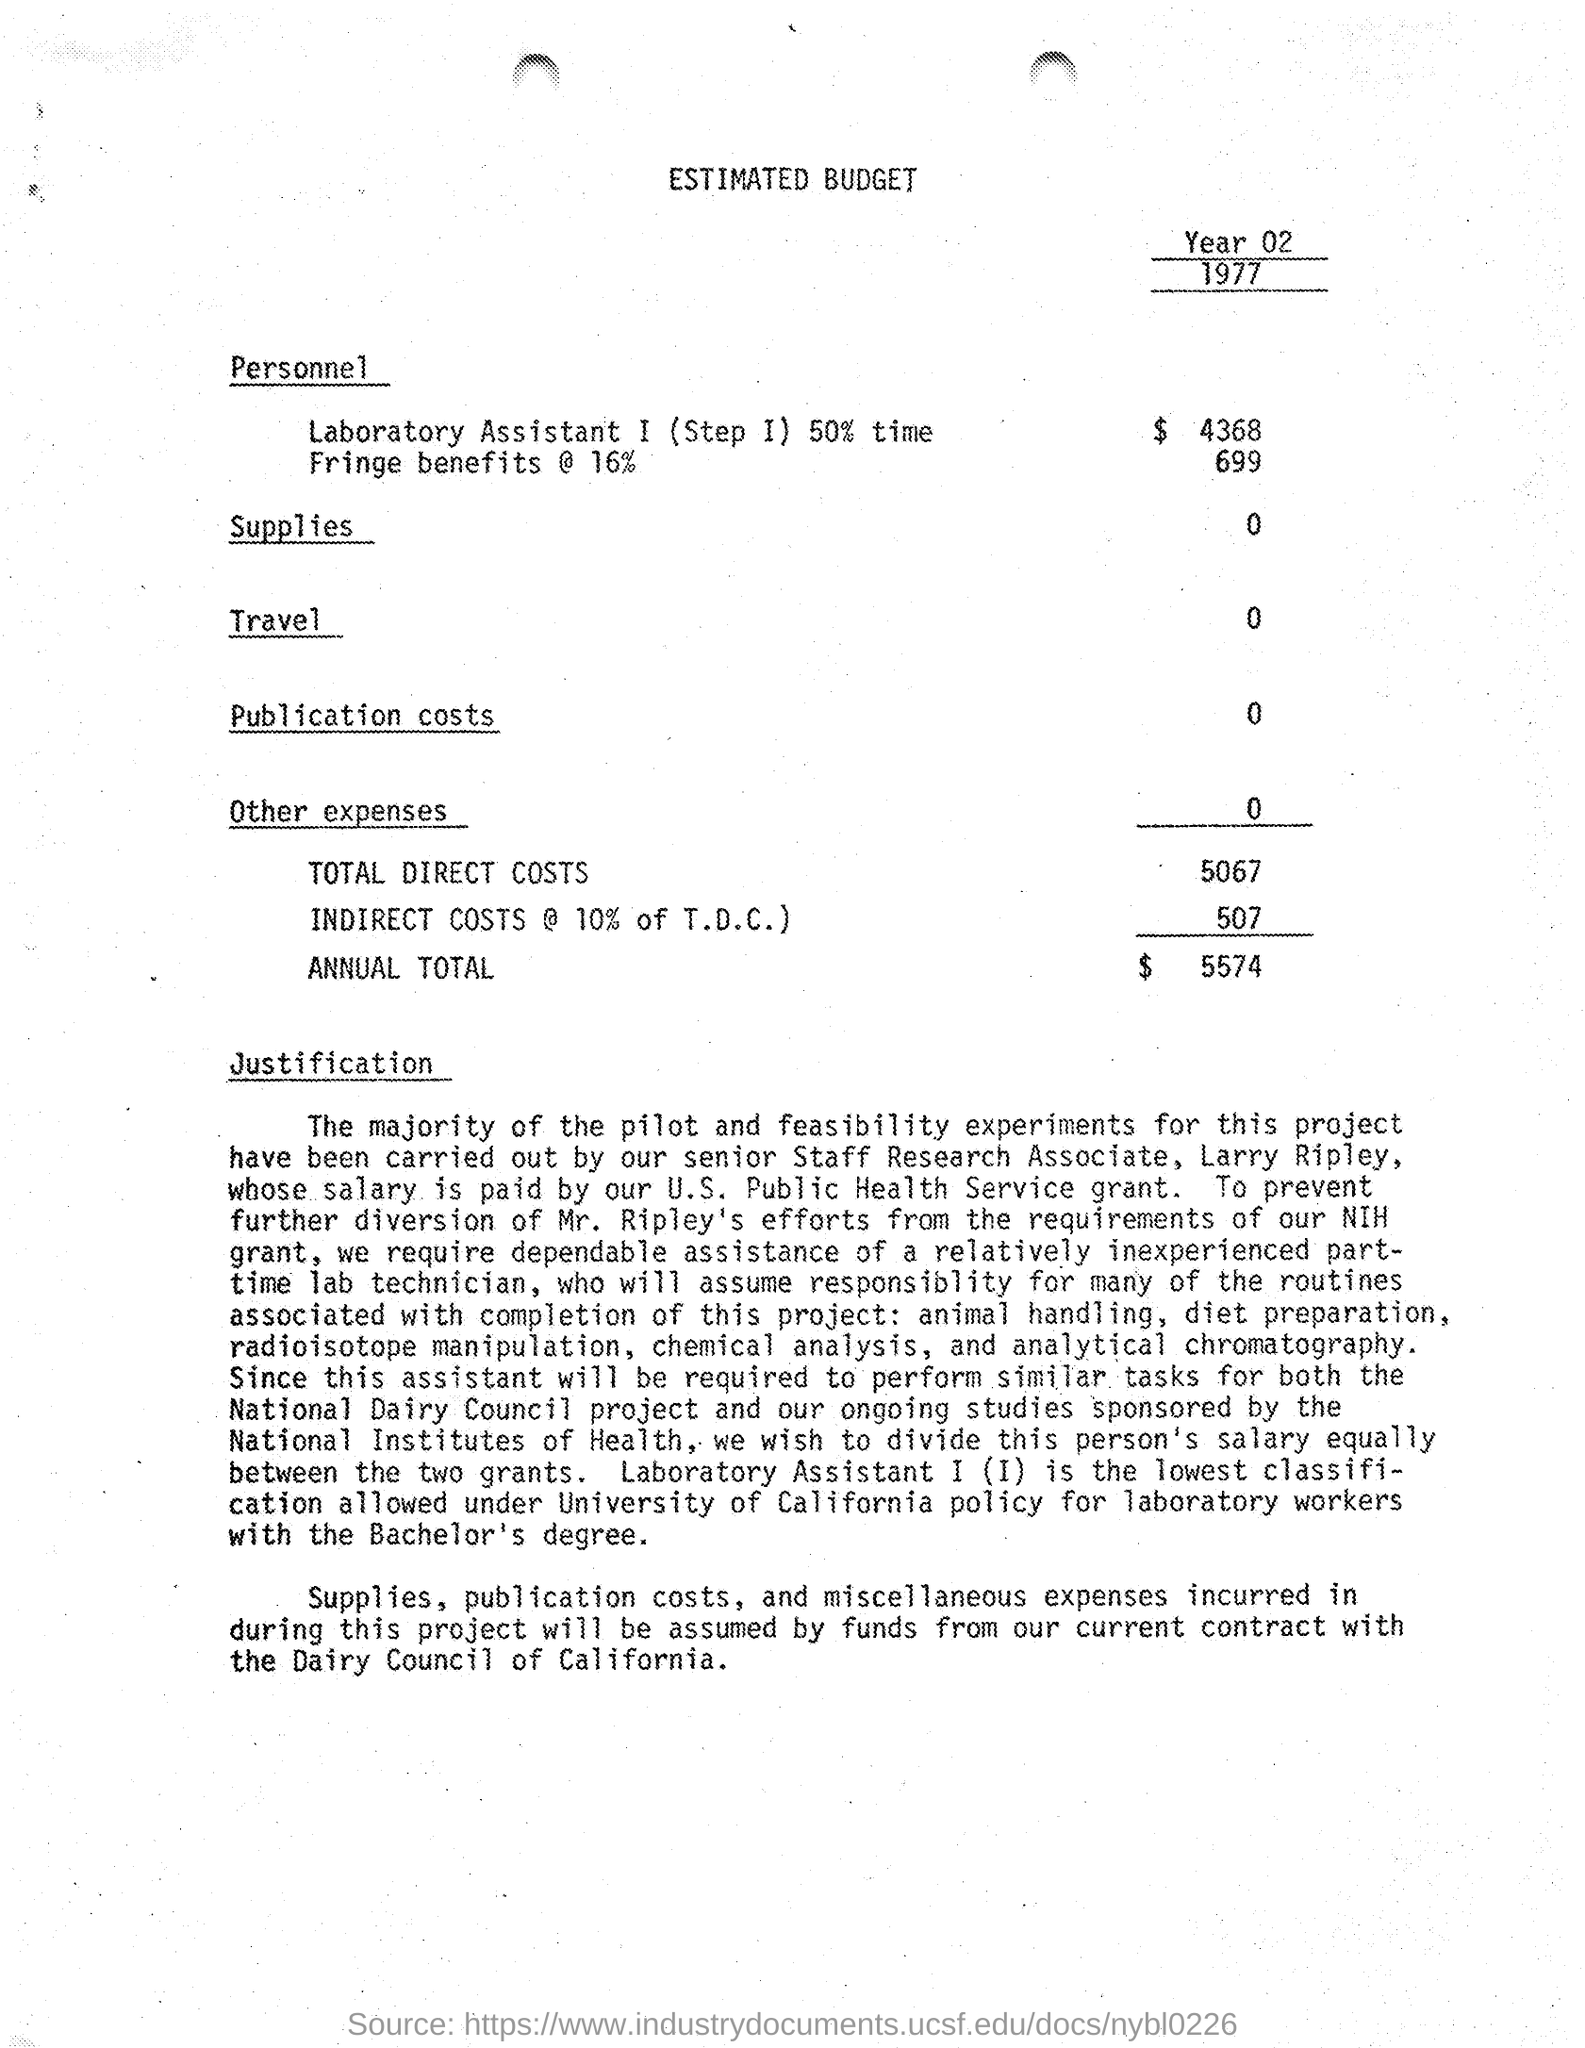Highlight a few significant elements in this photo. The total direct costs mentioned in the given budget are 5067... The amount allocated for fringe benefits in the given budget is 16%, which is equivalent to 699... The amount allocated for travel in the given budget is 0. The amount of indirect costs mentioned in the given budget is 507. The given budget mentions an annual total of 5574. 